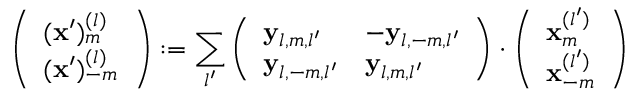Convert formula to latex. <formula><loc_0><loc_0><loc_500><loc_500>\left ( \begin{array} { l } { ( x ^ { \prime } ) _ { m } ^ { ( l ) } } \\ { ( x ^ { \prime } ) _ { - m } ^ { ( l ) } } \end{array} \right ) \colon = \sum _ { l ^ { \prime } } \left ( \begin{array} { l l } { y _ { l , m , l ^ { \prime } } } & { - y _ { l , - m , l ^ { \prime } } } \\ { y _ { l , - m , l ^ { \prime } } } & { y _ { l , m , l ^ { \prime } } } \end{array} \right ) \cdot \left ( \begin{array} { l } { x _ { m } ^ { ( l ^ { \prime } ) } } \\ { x _ { - m } ^ { ( l ^ { \prime } ) } } \end{array} \right )</formula> 